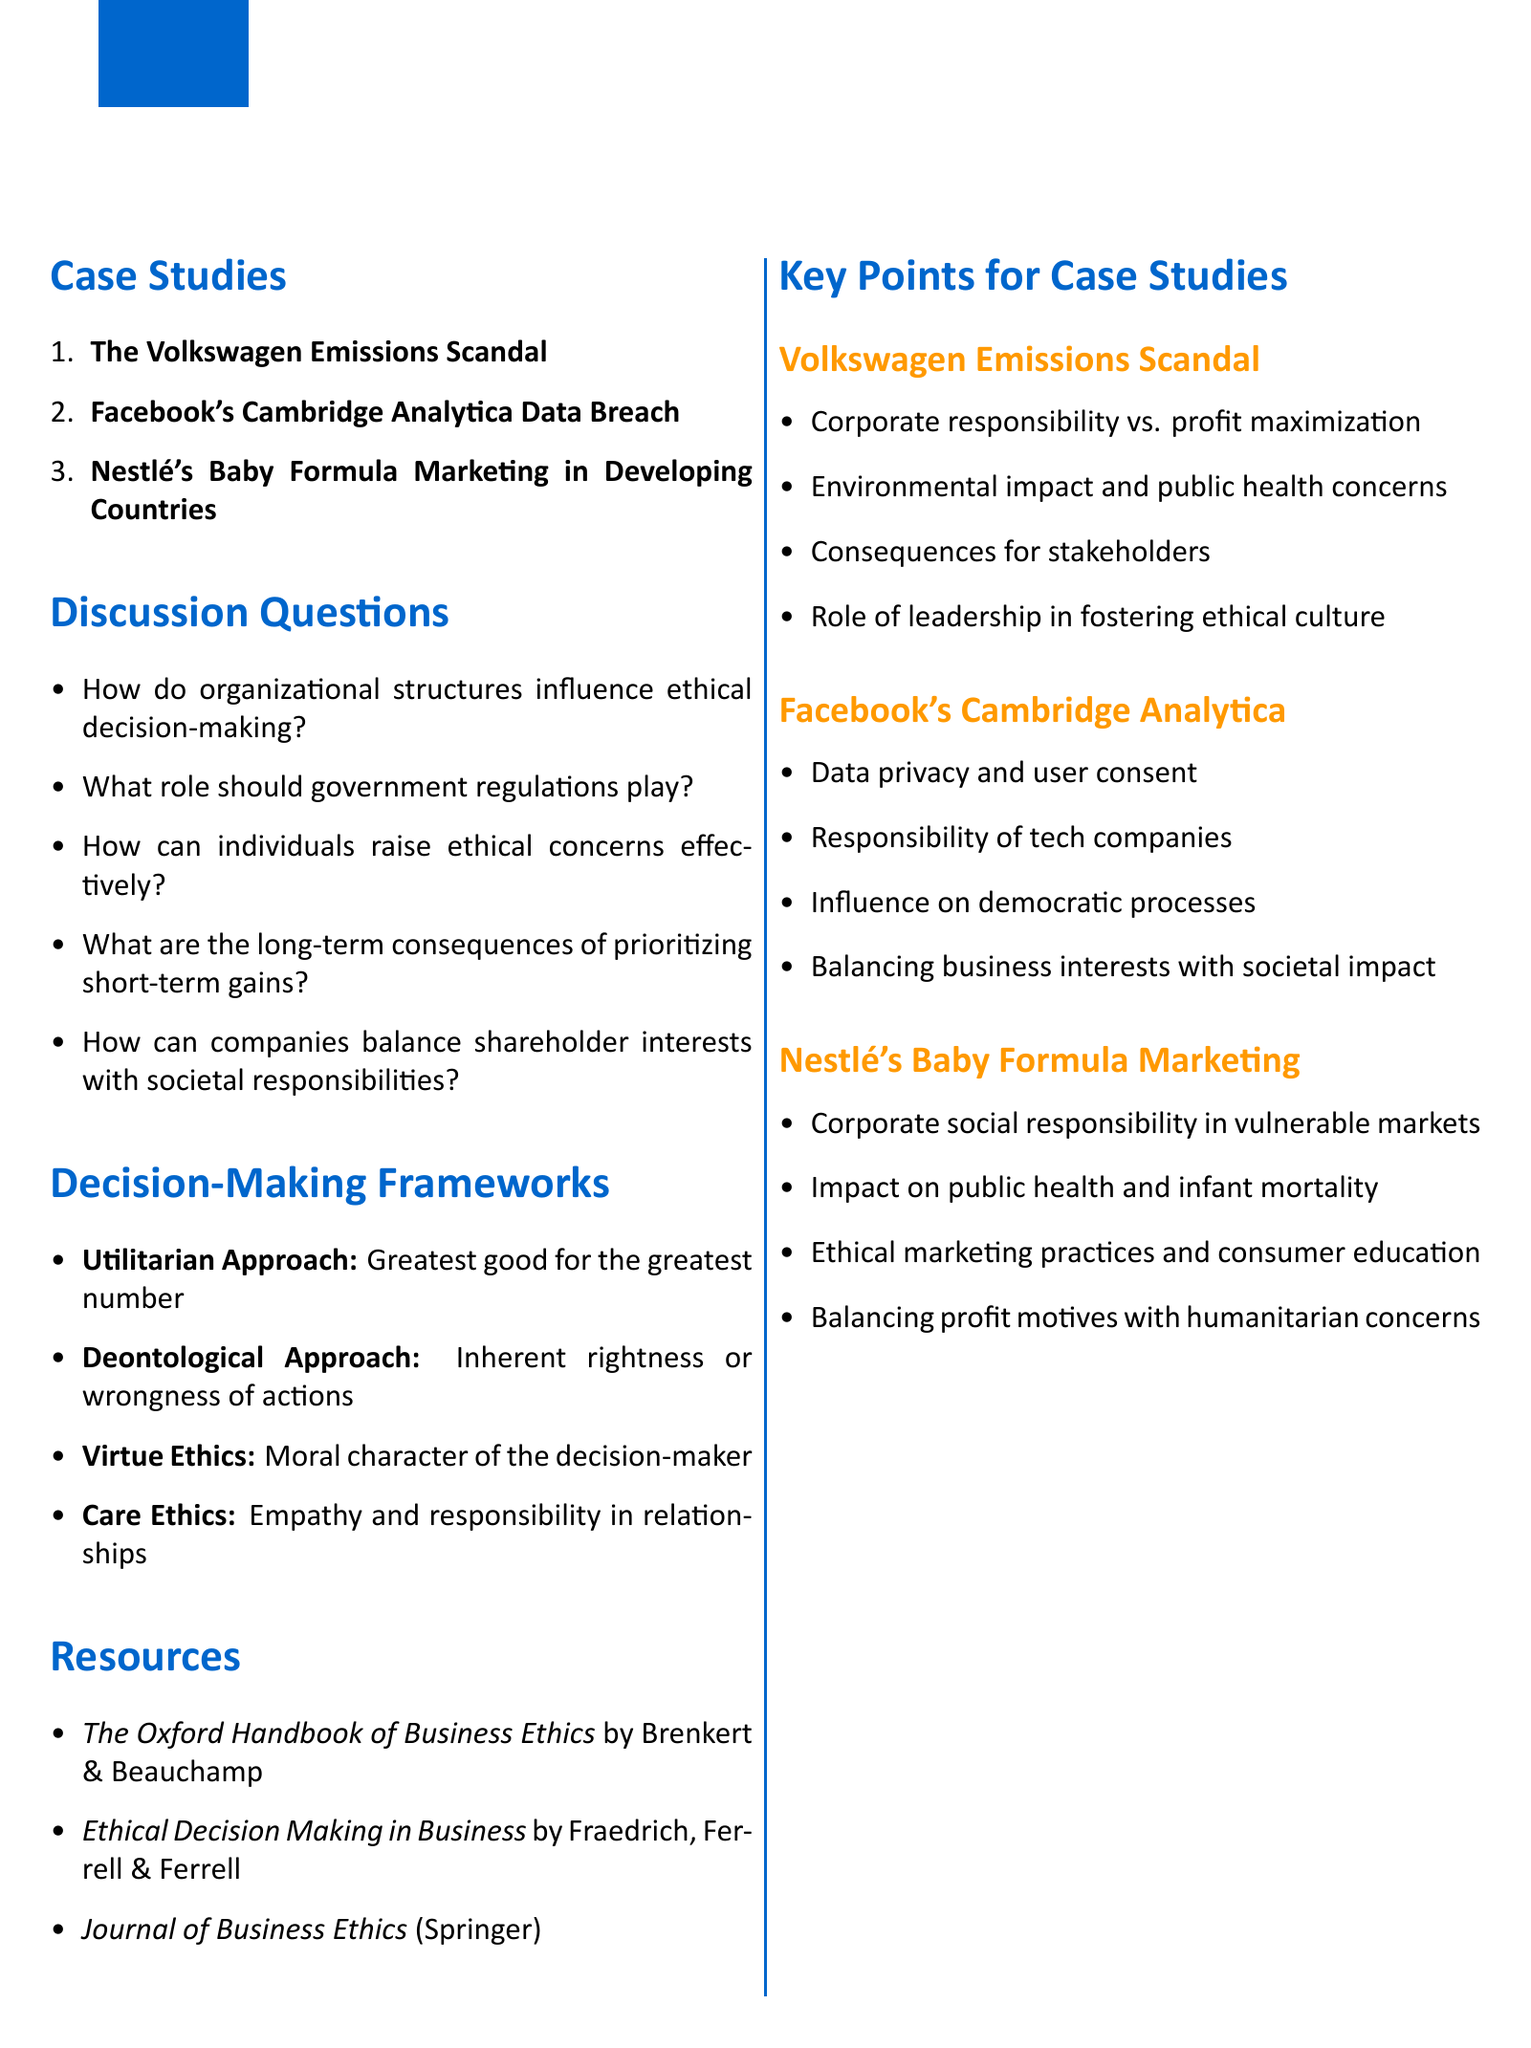What is the title of the document? The title is the main heading found at the beginning of the document, which is "Ethical Case Study Discussion: Analyze real-world ethical dilemmas and decision-making processes."
Answer: Ethical Case Study Discussion: Analyze real-world ethical dilemmas and decision-making processes How many case studies are discussed in the document? The total number of case studies is listed in the "Case Studies" section of the document, and there are three case studies mentioned.
Answer: 3 What is one key point of the Volkswagen emissions scandal? A key point is specifically mentioned in the "Key Points for Case Studies" section related to "Volkswagen Emissions Scandal."
Answer: Corporate responsibility vs. profit maximization Who are the authors of "The Oxford Handbook of Business Ethics"? The authors are specified in the "Resources" section, indicating who contributed to the listed resource.
Answer: George G. Brenkert and Tom L. Beauchamp What ethical approach focuses on the greatest good for the greatest number? The document describes ethical approaches, and the one that matches this description is outlined under "Decision-Making Frameworks."
Answer: Utilitarian Approach What is one of the discussion questions about government regulations? The discussion questions address various themes, and the one related to government regulations specifically asks about its role.
Answer: What role should government regulations play? 